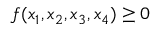Convert formula to latex. <formula><loc_0><loc_0><loc_500><loc_500>f ( x _ { 1 } , x _ { 2 } , x _ { 3 } , x _ { 4 } ) \geq 0</formula> 